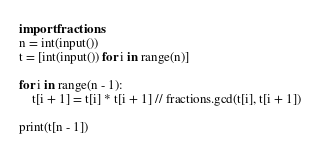Convert code to text. <code><loc_0><loc_0><loc_500><loc_500><_Python_>import fractions
n = int(input())
t = [int(input()) for i in range(n)]

for i in range(n - 1):
    t[i + 1] = t[i] * t[i + 1] // fractions.gcd(t[i], t[i + 1])

print(t[n - 1])
</code> 